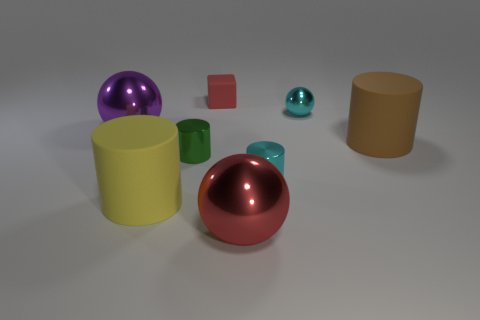Add 1 small matte blocks. How many objects exist? 9 Subtract all balls. How many objects are left? 5 Subtract 1 cyan cylinders. How many objects are left? 7 Subtract all large cylinders. Subtract all spheres. How many objects are left? 3 Add 4 brown cylinders. How many brown cylinders are left? 5 Add 8 matte cylinders. How many matte cylinders exist? 10 